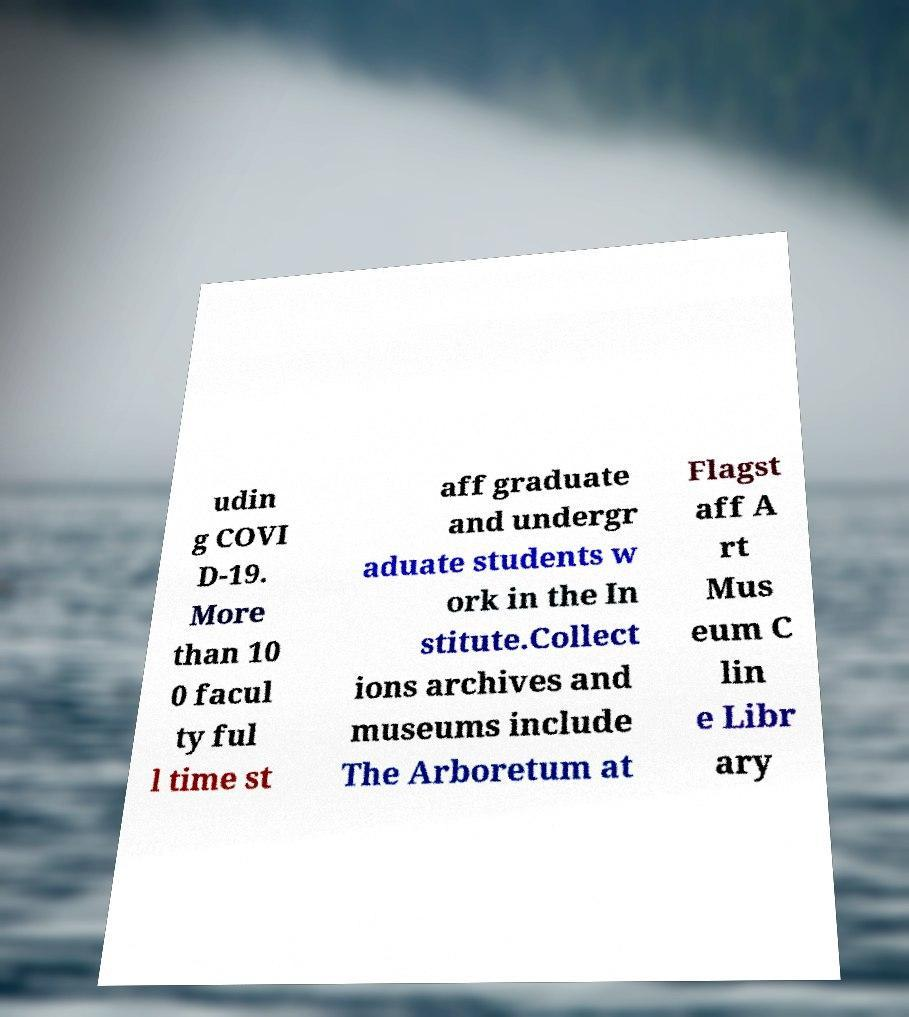Could you extract and type out the text from this image? udin g COVI D-19. More than 10 0 facul ty ful l time st aff graduate and undergr aduate students w ork in the In stitute.Collect ions archives and museums include The Arboretum at Flagst aff A rt Mus eum C lin e Libr ary 